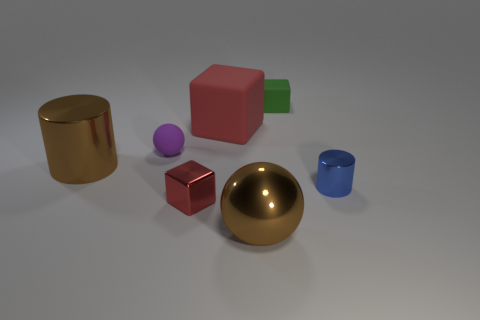Add 1 big brown spheres. How many objects exist? 8 Subtract all blocks. How many objects are left? 4 Subtract all small red metallic blocks. Subtract all tiny balls. How many objects are left? 5 Add 7 large things. How many large things are left? 10 Add 6 tiny yellow metallic cylinders. How many tiny yellow metallic cylinders exist? 6 Subtract 0 yellow spheres. How many objects are left? 7 